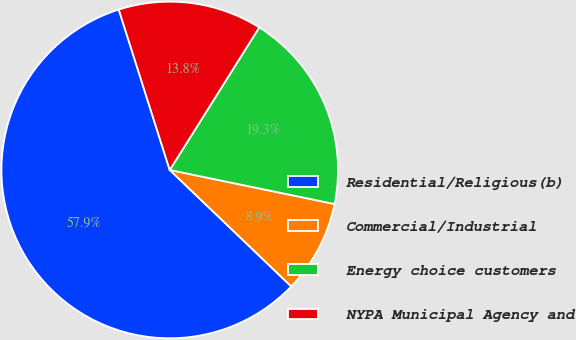Convert chart to OTSL. <chart><loc_0><loc_0><loc_500><loc_500><pie_chart><fcel>Residential/Religious(b)<fcel>Commercial/Industrial<fcel>Energy choice customers<fcel>NYPA Municipal Agency and<nl><fcel>57.95%<fcel>8.92%<fcel>19.32%<fcel>13.82%<nl></chart> 